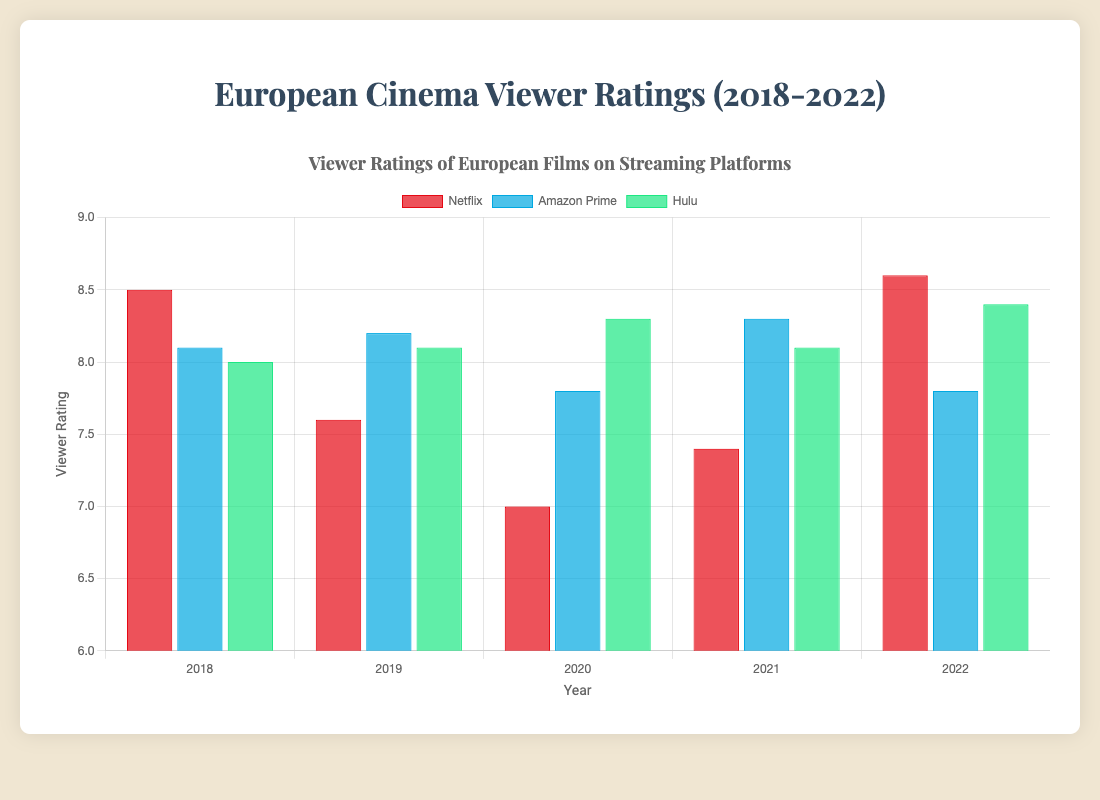Which year did Hulu have the highest viewer rating? To answer this, we need to look at the green bars representing Hulu on the chart. Compare the heights or values across the years. The highest bar for Hulu is in 2022.
Answer: 2022 Compare the viewer ratings of European films on Netflix in 2020 and 2021. Which year had a higher rating? Look for the red bars representing Netflix in the years 2020 and 2021. The height of the bar in 2021 (7.4) is higher than in 2020 (7.0).
Answer: 2021 What is the average viewer rating of Amazon Prime European films from 2018 to 2022? Sum the viewer ratings of Amazon Prime from 2018 to 2022 (8.1 + 8.2 + 7.8 + 8.3 + 7.8) and then divide by the number of years (5). This gives (40.2 / 5) = 8.04.
Answer: 8.04 Which platform had a higher viewer rating for European films in 2020, Amazon Prime or Hulu? Compare the heights of the blue bar (Amazon Prime) and the green bar (Hulu) for 2020. Amazon Prime is at 7.8 and Hulu is at 8.3. So Hulu had a higher rating.
Answer: Hulu In which year did Netflix have the lowest viewer rating? Look at the red bars representing Netflix across all five years and find the lowest one. The lowest bar is in 2020, with a rating of 7.0.
Answer: 2020 What is the difference between the highest and lowest viewer ratings for Hulu films over the 5 years? Identify Hulu's highest (8.4 in 2022) and lowest ratings (8.0 in 2018), then subtract the lowest from the highest (8.4 - 8.0).
Answer: 0.4 For which year and platform was the viewer rating exactly 8.3? Look for the year and platform where the bar height hits 8.3. This occurs twice: Hulu in 2020 and Amazon Prime in 2021.
Answer: 2020 (Hulu), 2021 (Amazon Prime) Which platform's viewer ratings showed the greatest increase from one year to the next between any two consecutive years? Calculate the year-to-year differences for each platform and identify the largest increase. Netflix shows the greatest increase from 2021 (7.4) to 2022 (8.6), which is an increase of 1.2.
Answer: Netflix (2021 to 2022) If you were to rank the platforms based on their average viewer ratings over the 5 years, what would the ranking be from highest to lowest? Calculate the average ratings for each platform over the 5 years: 
Netflix: (8.5 + 7.6 + 7.0 + 7.4 + 8.6) / 5 = 7.82
Amazon Prime: (8.1 + 8.2 + 7.8 + 8.3 + 7.8) / 5 = 8.04
Hulu: (8.0 + 8.1 + 8.3 + 8.1 + 8.4) / 5 = 8.18
Rank from highest to lowest is Hulu, Amazon Prime, Netflix.
Answer: Hulu, Amazon Prime, Netflix 